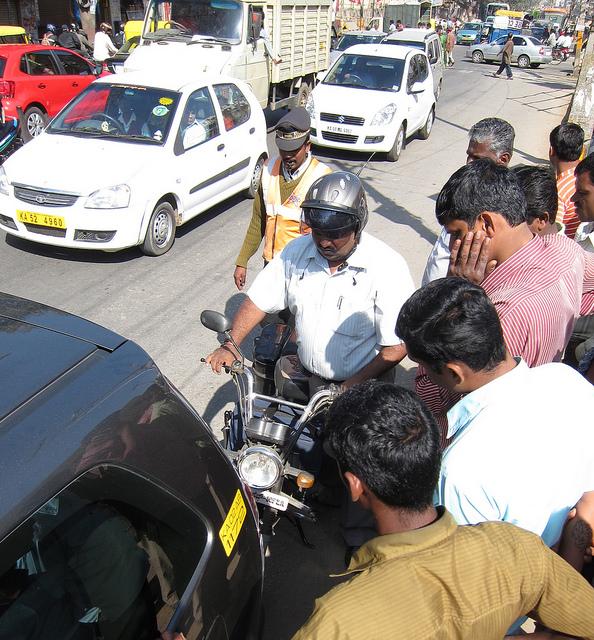Do you see a motorcycle?
Quick response, please. Yes. Do all of the men near the motorcycle have the same hair color?
Short answer required. Yes. What vehicles are in the photo?
Answer briefly. Cars. 